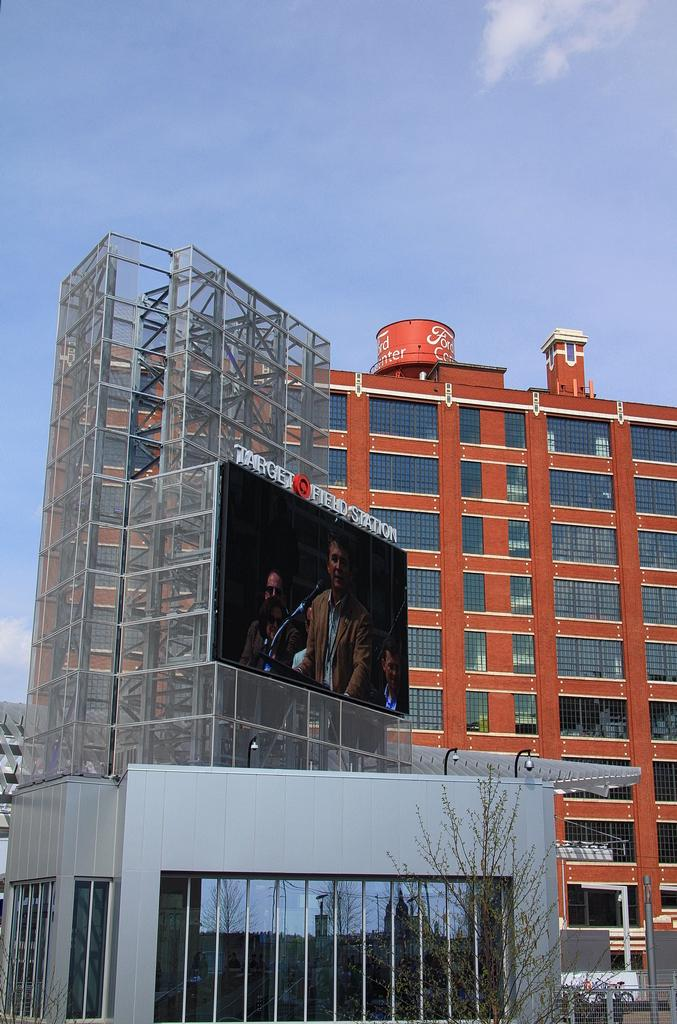What is the main object in the center of the image? There is a screen in the center of the image. How is the screen connected to its surroundings? The screen is attached to a building. What type of vegetation is at the bottom of the image? There is a tree at the bottom of the image. What can be seen in the distance behind the screen? There are buildings visible in the background, and the sky with clouds is also visible. What type of berry is growing on the screen in the image? There are no berries present on the screen in the image; it is a screen attached to a building. 